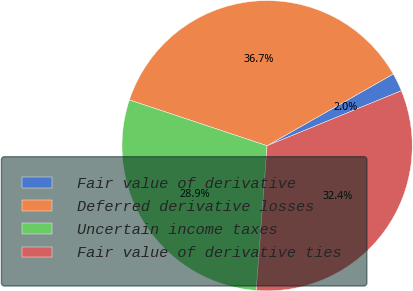Convert chart. <chart><loc_0><loc_0><loc_500><loc_500><pie_chart><fcel>Fair value of derivative<fcel>Deferred derivative losses<fcel>Uncertain income taxes<fcel>Fair value of derivative ties<nl><fcel>2.04%<fcel>36.66%<fcel>28.92%<fcel>32.38%<nl></chart> 